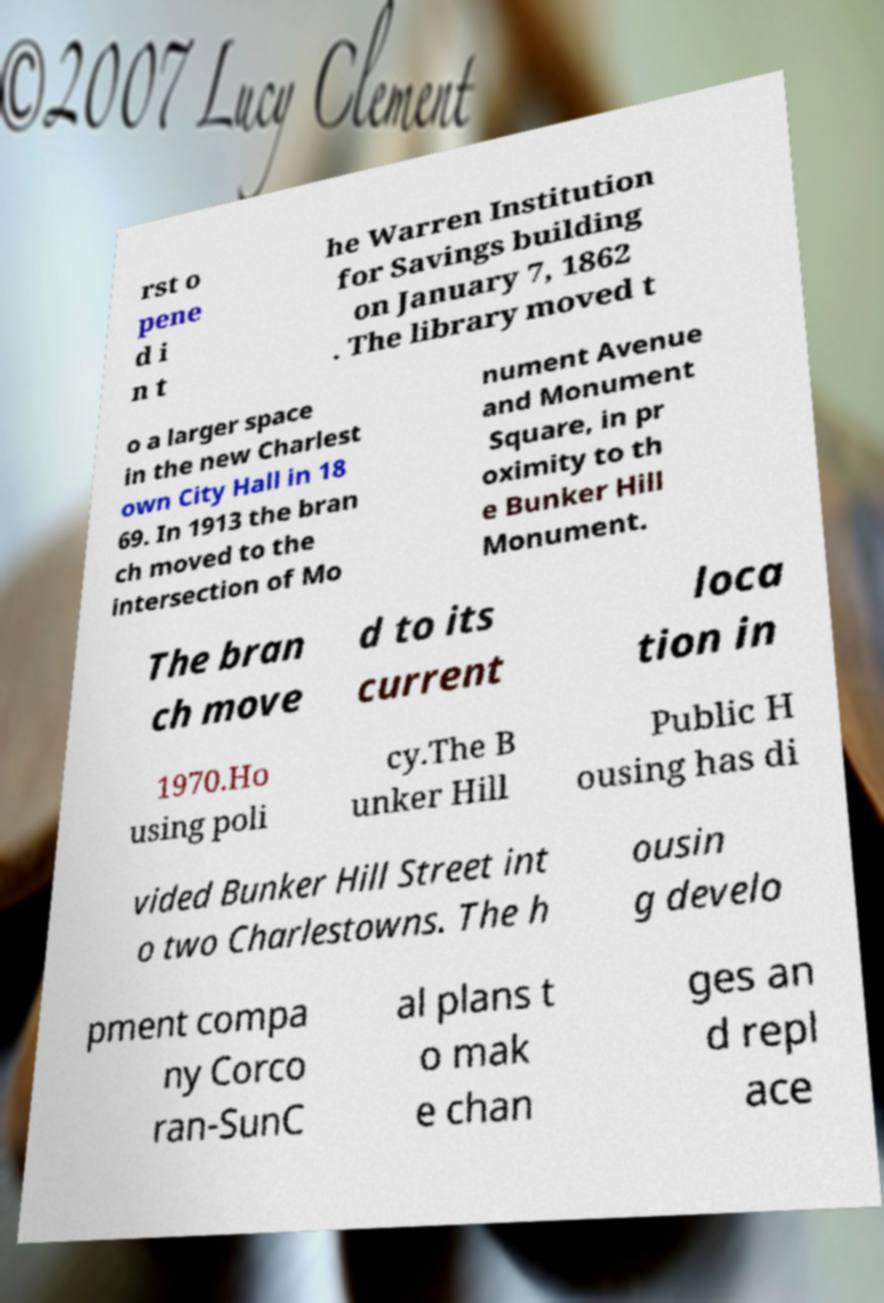Please read and relay the text visible in this image. What does it say? rst o pene d i n t he Warren Institution for Savings building on January 7, 1862 . The library moved t o a larger space in the new Charlest own City Hall in 18 69. In 1913 the bran ch moved to the intersection of Mo nument Avenue and Monument Square, in pr oximity to th e Bunker Hill Monument. The bran ch move d to its current loca tion in 1970.Ho using poli cy.The B unker Hill Public H ousing has di vided Bunker Hill Street int o two Charlestowns. The h ousin g develo pment compa ny Corco ran-SunC al plans t o mak e chan ges an d repl ace 